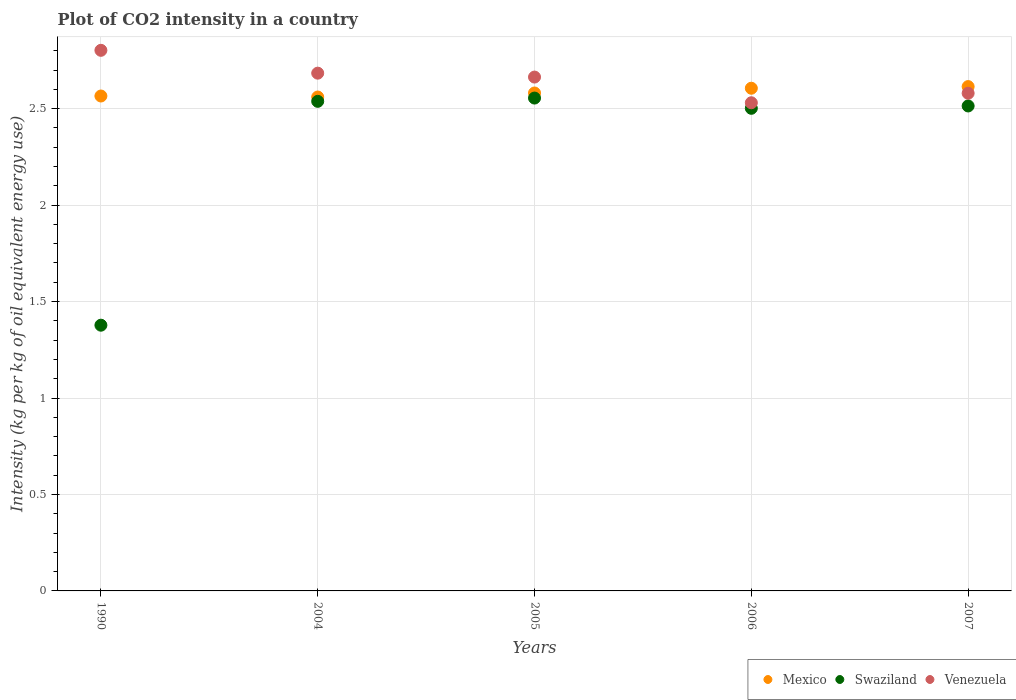What is the CO2 intensity in in Venezuela in 2005?
Your answer should be compact. 2.66. Across all years, what is the maximum CO2 intensity in in Swaziland?
Provide a short and direct response. 2.55. Across all years, what is the minimum CO2 intensity in in Mexico?
Your response must be concise. 2.56. In which year was the CO2 intensity in in Venezuela maximum?
Ensure brevity in your answer.  1990. What is the total CO2 intensity in in Venezuela in the graph?
Your answer should be compact. 13.26. What is the difference between the CO2 intensity in in Mexico in 1990 and that in 2007?
Make the answer very short. -0.05. What is the difference between the CO2 intensity in in Swaziland in 1990 and the CO2 intensity in in Mexico in 2007?
Make the answer very short. -1.24. What is the average CO2 intensity in in Mexico per year?
Offer a terse response. 2.59. In the year 2007, what is the difference between the CO2 intensity in in Venezuela and CO2 intensity in in Mexico?
Your response must be concise. -0.03. What is the ratio of the CO2 intensity in in Swaziland in 1990 to that in 2004?
Offer a very short reply. 0.54. Is the CO2 intensity in in Swaziland in 1990 less than that in 2005?
Give a very brief answer. Yes. Is the difference between the CO2 intensity in in Venezuela in 2004 and 2007 greater than the difference between the CO2 intensity in in Mexico in 2004 and 2007?
Keep it short and to the point. Yes. What is the difference between the highest and the second highest CO2 intensity in in Mexico?
Make the answer very short. 0.01. What is the difference between the highest and the lowest CO2 intensity in in Swaziland?
Make the answer very short. 1.18. In how many years, is the CO2 intensity in in Venezuela greater than the average CO2 intensity in in Venezuela taken over all years?
Keep it short and to the point. 3. Is the CO2 intensity in in Venezuela strictly greater than the CO2 intensity in in Swaziland over the years?
Provide a succinct answer. Yes. Is the CO2 intensity in in Venezuela strictly less than the CO2 intensity in in Mexico over the years?
Provide a succinct answer. No. What is the difference between two consecutive major ticks on the Y-axis?
Keep it short and to the point. 0.5. Does the graph contain any zero values?
Provide a short and direct response. No. Does the graph contain grids?
Ensure brevity in your answer.  Yes. Where does the legend appear in the graph?
Keep it short and to the point. Bottom right. What is the title of the graph?
Give a very brief answer. Plot of CO2 intensity in a country. What is the label or title of the Y-axis?
Your response must be concise. Intensity (kg per kg of oil equivalent energy use). What is the Intensity (kg per kg of oil equivalent energy use) in Mexico in 1990?
Make the answer very short. 2.57. What is the Intensity (kg per kg of oil equivalent energy use) of Swaziland in 1990?
Offer a very short reply. 1.38. What is the Intensity (kg per kg of oil equivalent energy use) of Venezuela in 1990?
Offer a terse response. 2.8. What is the Intensity (kg per kg of oil equivalent energy use) in Mexico in 2004?
Provide a succinct answer. 2.56. What is the Intensity (kg per kg of oil equivalent energy use) in Swaziland in 2004?
Your response must be concise. 2.54. What is the Intensity (kg per kg of oil equivalent energy use) in Venezuela in 2004?
Provide a succinct answer. 2.68. What is the Intensity (kg per kg of oil equivalent energy use) in Mexico in 2005?
Ensure brevity in your answer.  2.58. What is the Intensity (kg per kg of oil equivalent energy use) in Swaziland in 2005?
Keep it short and to the point. 2.55. What is the Intensity (kg per kg of oil equivalent energy use) in Venezuela in 2005?
Give a very brief answer. 2.66. What is the Intensity (kg per kg of oil equivalent energy use) in Mexico in 2006?
Your answer should be compact. 2.61. What is the Intensity (kg per kg of oil equivalent energy use) of Swaziland in 2006?
Provide a succinct answer. 2.5. What is the Intensity (kg per kg of oil equivalent energy use) in Venezuela in 2006?
Keep it short and to the point. 2.53. What is the Intensity (kg per kg of oil equivalent energy use) in Mexico in 2007?
Offer a terse response. 2.61. What is the Intensity (kg per kg of oil equivalent energy use) in Swaziland in 2007?
Provide a succinct answer. 2.51. What is the Intensity (kg per kg of oil equivalent energy use) of Venezuela in 2007?
Provide a short and direct response. 2.58. Across all years, what is the maximum Intensity (kg per kg of oil equivalent energy use) in Mexico?
Your response must be concise. 2.61. Across all years, what is the maximum Intensity (kg per kg of oil equivalent energy use) in Swaziland?
Keep it short and to the point. 2.55. Across all years, what is the maximum Intensity (kg per kg of oil equivalent energy use) in Venezuela?
Provide a succinct answer. 2.8. Across all years, what is the minimum Intensity (kg per kg of oil equivalent energy use) in Mexico?
Offer a terse response. 2.56. Across all years, what is the minimum Intensity (kg per kg of oil equivalent energy use) of Swaziland?
Make the answer very short. 1.38. Across all years, what is the minimum Intensity (kg per kg of oil equivalent energy use) in Venezuela?
Offer a terse response. 2.53. What is the total Intensity (kg per kg of oil equivalent energy use) of Mexico in the graph?
Give a very brief answer. 12.93. What is the total Intensity (kg per kg of oil equivalent energy use) of Swaziland in the graph?
Keep it short and to the point. 11.49. What is the total Intensity (kg per kg of oil equivalent energy use) of Venezuela in the graph?
Keep it short and to the point. 13.26. What is the difference between the Intensity (kg per kg of oil equivalent energy use) in Mexico in 1990 and that in 2004?
Provide a short and direct response. 0.01. What is the difference between the Intensity (kg per kg of oil equivalent energy use) in Swaziland in 1990 and that in 2004?
Ensure brevity in your answer.  -1.16. What is the difference between the Intensity (kg per kg of oil equivalent energy use) in Venezuela in 1990 and that in 2004?
Offer a very short reply. 0.12. What is the difference between the Intensity (kg per kg of oil equivalent energy use) of Mexico in 1990 and that in 2005?
Your answer should be very brief. -0.02. What is the difference between the Intensity (kg per kg of oil equivalent energy use) of Swaziland in 1990 and that in 2005?
Ensure brevity in your answer.  -1.18. What is the difference between the Intensity (kg per kg of oil equivalent energy use) of Venezuela in 1990 and that in 2005?
Make the answer very short. 0.14. What is the difference between the Intensity (kg per kg of oil equivalent energy use) of Mexico in 1990 and that in 2006?
Keep it short and to the point. -0.04. What is the difference between the Intensity (kg per kg of oil equivalent energy use) in Swaziland in 1990 and that in 2006?
Make the answer very short. -1.12. What is the difference between the Intensity (kg per kg of oil equivalent energy use) of Venezuela in 1990 and that in 2006?
Your answer should be compact. 0.27. What is the difference between the Intensity (kg per kg of oil equivalent energy use) of Mexico in 1990 and that in 2007?
Provide a succinct answer. -0.05. What is the difference between the Intensity (kg per kg of oil equivalent energy use) in Swaziland in 1990 and that in 2007?
Provide a succinct answer. -1.14. What is the difference between the Intensity (kg per kg of oil equivalent energy use) of Venezuela in 1990 and that in 2007?
Keep it short and to the point. 0.22. What is the difference between the Intensity (kg per kg of oil equivalent energy use) in Mexico in 2004 and that in 2005?
Offer a terse response. -0.02. What is the difference between the Intensity (kg per kg of oil equivalent energy use) of Swaziland in 2004 and that in 2005?
Offer a terse response. -0.02. What is the difference between the Intensity (kg per kg of oil equivalent energy use) in Venezuela in 2004 and that in 2005?
Your answer should be compact. 0.02. What is the difference between the Intensity (kg per kg of oil equivalent energy use) in Mexico in 2004 and that in 2006?
Offer a terse response. -0.05. What is the difference between the Intensity (kg per kg of oil equivalent energy use) in Swaziland in 2004 and that in 2006?
Your response must be concise. 0.04. What is the difference between the Intensity (kg per kg of oil equivalent energy use) in Venezuela in 2004 and that in 2006?
Your response must be concise. 0.15. What is the difference between the Intensity (kg per kg of oil equivalent energy use) in Mexico in 2004 and that in 2007?
Make the answer very short. -0.05. What is the difference between the Intensity (kg per kg of oil equivalent energy use) of Swaziland in 2004 and that in 2007?
Give a very brief answer. 0.02. What is the difference between the Intensity (kg per kg of oil equivalent energy use) of Venezuela in 2004 and that in 2007?
Provide a succinct answer. 0.1. What is the difference between the Intensity (kg per kg of oil equivalent energy use) of Mexico in 2005 and that in 2006?
Offer a terse response. -0.02. What is the difference between the Intensity (kg per kg of oil equivalent energy use) in Swaziland in 2005 and that in 2006?
Your answer should be compact. 0.05. What is the difference between the Intensity (kg per kg of oil equivalent energy use) of Venezuela in 2005 and that in 2006?
Provide a succinct answer. 0.13. What is the difference between the Intensity (kg per kg of oil equivalent energy use) in Mexico in 2005 and that in 2007?
Provide a short and direct response. -0.03. What is the difference between the Intensity (kg per kg of oil equivalent energy use) of Swaziland in 2005 and that in 2007?
Keep it short and to the point. 0.04. What is the difference between the Intensity (kg per kg of oil equivalent energy use) of Venezuela in 2005 and that in 2007?
Your answer should be very brief. 0.08. What is the difference between the Intensity (kg per kg of oil equivalent energy use) in Mexico in 2006 and that in 2007?
Keep it short and to the point. -0.01. What is the difference between the Intensity (kg per kg of oil equivalent energy use) in Swaziland in 2006 and that in 2007?
Keep it short and to the point. -0.01. What is the difference between the Intensity (kg per kg of oil equivalent energy use) of Venezuela in 2006 and that in 2007?
Offer a terse response. -0.05. What is the difference between the Intensity (kg per kg of oil equivalent energy use) in Mexico in 1990 and the Intensity (kg per kg of oil equivalent energy use) in Swaziland in 2004?
Provide a short and direct response. 0.03. What is the difference between the Intensity (kg per kg of oil equivalent energy use) in Mexico in 1990 and the Intensity (kg per kg of oil equivalent energy use) in Venezuela in 2004?
Make the answer very short. -0.12. What is the difference between the Intensity (kg per kg of oil equivalent energy use) in Swaziland in 1990 and the Intensity (kg per kg of oil equivalent energy use) in Venezuela in 2004?
Provide a short and direct response. -1.31. What is the difference between the Intensity (kg per kg of oil equivalent energy use) in Mexico in 1990 and the Intensity (kg per kg of oil equivalent energy use) in Swaziland in 2005?
Ensure brevity in your answer.  0.01. What is the difference between the Intensity (kg per kg of oil equivalent energy use) of Mexico in 1990 and the Intensity (kg per kg of oil equivalent energy use) of Venezuela in 2005?
Make the answer very short. -0.1. What is the difference between the Intensity (kg per kg of oil equivalent energy use) of Swaziland in 1990 and the Intensity (kg per kg of oil equivalent energy use) of Venezuela in 2005?
Make the answer very short. -1.29. What is the difference between the Intensity (kg per kg of oil equivalent energy use) in Mexico in 1990 and the Intensity (kg per kg of oil equivalent energy use) in Swaziland in 2006?
Your answer should be compact. 0.06. What is the difference between the Intensity (kg per kg of oil equivalent energy use) of Mexico in 1990 and the Intensity (kg per kg of oil equivalent energy use) of Venezuela in 2006?
Ensure brevity in your answer.  0.04. What is the difference between the Intensity (kg per kg of oil equivalent energy use) in Swaziland in 1990 and the Intensity (kg per kg of oil equivalent energy use) in Venezuela in 2006?
Your response must be concise. -1.15. What is the difference between the Intensity (kg per kg of oil equivalent energy use) in Mexico in 1990 and the Intensity (kg per kg of oil equivalent energy use) in Swaziland in 2007?
Your answer should be compact. 0.05. What is the difference between the Intensity (kg per kg of oil equivalent energy use) of Mexico in 1990 and the Intensity (kg per kg of oil equivalent energy use) of Venezuela in 2007?
Offer a terse response. -0.01. What is the difference between the Intensity (kg per kg of oil equivalent energy use) in Swaziland in 1990 and the Intensity (kg per kg of oil equivalent energy use) in Venezuela in 2007?
Ensure brevity in your answer.  -1.2. What is the difference between the Intensity (kg per kg of oil equivalent energy use) of Mexico in 2004 and the Intensity (kg per kg of oil equivalent energy use) of Swaziland in 2005?
Ensure brevity in your answer.  0.01. What is the difference between the Intensity (kg per kg of oil equivalent energy use) in Mexico in 2004 and the Intensity (kg per kg of oil equivalent energy use) in Venezuela in 2005?
Your response must be concise. -0.1. What is the difference between the Intensity (kg per kg of oil equivalent energy use) of Swaziland in 2004 and the Intensity (kg per kg of oil equivalent energy use) of Venezuela in 2005?
Keep it short and to the point. -0.13. What is the difference between the Intensity (kg per kg of oil equivalent energy use) of Mexico in 2004 and the Intensity (kg per kg of oil equivalent energy use) of Swaziland in 2006?
Your response must be concise. 0.06. What is the difference between the Intensity (kg per kg of oil equivalent energy use) of Mexico in 2004 and the Intensity (kg per kg of oil equivalent energy use) of Venezuela in 2006?
Provide a short and direct response. 0.03. What is the difference between the Intensity (kg per kg of oil equivalent energy use) of Swaziland in 2004 and the Intensity (kg per kg of oil equivalent energy use) of Venezuela in 2006?
Your answer should be compact. 0.01. What is the difference between the Intensity (kg per kg of oil equivalent energy use) of Mexico in 2004 and the Intensity (kg per kg of oil equivalent energy use) of Swaziland in 2007?
Provide a short and direct response. 0.05. What is the difference between the Intensity (kg per kg of oil equivalent energy use) of Mexico in 2004 and the Intensity (kg per kg of oil equivalent energy use) of Venezuela in 2007?
Keep it short and to the point. -0.02. What is the difference between the Intensity (kg per kg of oil equivalent energy use) in Swaziland in 2004 and the Intensity (kg per kg of oil equivalent energy use) in Venezuela in 2007?
Provide a short and direct response. -0.04. What is the difference between the Intensity (kg per kg of oil equivalent energy use) of Mexico in 2005 and the Intensity (kg per kg of oil equivalent energy use) of Swaziland in 2006?
Make the answer very short. 0.08. What is the difference between the Intensity (kg per kg of oil equivalent energy use) in Mexico in 2005 and the Intensity (kg per kg of oil equivalent energy use) in Venezuela in 2006?
Your answer should be very brief. 0.05. What is the difference between the Intensity (kg per kg of oil equivalent energy use) of Swaziland in 2005 and the Intensity (kg per kg of oil equivalent energy use) of Venezuela in 2006?
Make the answer very short. 0.02. What is the difference between the Intensity (kg per kg of oil equivalent energy use) in Mexico in 2005 and the Intensity (kg per kg of oil equivalent energy use) in Swaziland in 2007?
Make the answer very short. 0.07. What is the difference between the Intensity (kg per kg of oil equivalent energy use) in Mexico in 2005 and the Intensity (kg per kg of oil equivalent energy use) in Venezuela in 2007?
Offer a very short reply. 0. What is the difference between the Intensity (kg per kg of oil equivalent energy use) in Swaziland in 2005 and the Intensity (kg per kg of oil equivalent energy use) in Venezuela in 2007?
Provide a succinct answer. -0.03. What is the difference between the Intensity (kg per kg of oil equivalent energy use) in Mexico in 2006 and the Intensity (kg per kg of oil equivalent energy use) in Swaziland in 2007?
Offer a very short reply. 0.09. What is the difference between the Intensity (kg per kg of oil equivalent energy use) in Mexico in 2006 and the Intensity (kg per kg of oil equivalent energy use) in Venezuela in 2007?
Offer a very short reply. 0.03. What is the difference between the Intensity (kg per kg of oil equivalent energy use) of Swaziland in 2006 and the Intensity (kg per kg of oil equivalent energy use) of Venezuela in 2007?
Offer a very short reply. -0.08. What is the average Intensity (kg per kg of oil equivalent energy use) in Mexico per year?
Your answer should be compact. 2.59. What is the average Intensity (kg per kg of oil equivalent energy use) of Swaziland per year?
Ensure brevity in your answer.  2.3. What is the average Intensity (kg per kg of oil equivalent energy use) of Venezuela per year?
Provide a short and direct response. 2.65. In the year 1990, what is the difference between the Intensity (kg per kg of oil equivalent energy use) of Mexico and Intensity (kg per kg of oil equivalent energy use) of Swaziland?
Provide a succinct answer. 1.19. In the year 1990, what is the difference between the Intensity (kg per kg of oil equivalent energy use) of Mexico and Intensity (kg per kg of oil equivalent energy use) of Venezuela?
Keep it short and to the point. -0.24. In the year 1990, what is the difference between the Intensity (kg per kg of oil equivalent energy use) of Swaziland and Intensity (kg per kg of oil equivalent energy use) of Venezuela?
Provide a short and direct response. -1.43. In the year 2004, what is the difference between the Intensity (kg per kg of oil equivalent energy use) of Mexico and Intensity (kg per kg of oil equivalent energy use) of Swaziland?
Offer a very short reply. 0.02. In the year 2004, what is the difference between the Intensity (kg per kg of oil equivalent energy use) in Mexico and Intensity (kg per kg of oil equivalent energy use) in Venezuela?
Offer a very short reply. -0.12. In the year 2004, what is the difference between the Intensity (kg per kg of oil equivalent energy use) in Swaziland and Intensity (kg per kg of oil equivalent energy use) in Venezuela?
Your response must be concise. -0.15. In the year 2005, what is the difference between the Intensity (kg per kg of oil equivalent energy use) in Mexico and Intensity (kg per kg of oil equivalent energy use) in Swaziland?
Provide a short and direct response. 0.03. In the year 2005, what is the difference between the Intensity (kg per kg of oil equivalent energy use) of Mexico and Intensity (kg per kg of oil equivalent energy use) of Venezuela?
Ensure brevity in your answer.  -0.08. In the year 2005, what is the difference between the Intensity (kg per kg of oil equivalent energy use) of Swaziland and Intensity (kg per kg of oil equivalent energy use) of Venezuela?
Your answer should be very brief. -0.11. In the year 2006, what is the difference between the Intensity (kg per kg of oil equivalent energy use) of Mexico and Intensity (kg per kg of oil equivalent energy use) of Swaziland?
Your answer should be very brief. 0.1. In the year 2006, what is the difference between the Intensity (kg per kg of oil equivalent energy use) in Mexico and Intensity (kg per kg of oil equivalent energy use) in Venezuela?
Your response must be concise. 0.08. In the year 2006, what is the difference between the Intensity (kg per kg of oil equivalent energy use) of Swaziland and Intensity (kg per kg of oil equivalent energy use) of Venezuela?
Provide a succinct answer. -0.03. In the year 2007, what is the difference between the Intensity (kg per kg of oil equivalent energy use) of Mexico and Intensity (kg per kg of oil equivalent energy use) of Swaziland?
Ensure brevity in your answer.  0.1. In the year 2007, what is the difference between the Intensity (kg per kg of oil equivalent energy use) of Mexico and Intensity (kg per kg of oil equivalent energy use) of Venezuela?
Ensure brevity in your answer.  0.03. In the year 2007, what is the difference between the Intensity (kg per kg of oil equivalent energy use) of Swaziland and Intensity (kg per kg of oil equivalent energy use) of Venezuela?
Keep it short and to the point. -0.07. What is the ratio of the Intensity (kg per kg of oil equivalent energy use) in Swaziland in 1990 to that in 2004?
Keep it short and to the point. 0.54. What is the ratio of the Intensity (kg per kg of oil equivalent energy use) in Venezuela in 1990 to that in 2004?
Your answer should be very brief. 1.04. What is the ratio of the Intensity (kg per kg of oil equivalent energy use) of Mexico in 1990 to that in 2005?
Ensure brevity in your answer.  0.99. What is the ratio of the Intensity (kg per kg of oil equivalent energy use) of Swaziland in 1990 to that in 2005?
Your answer should be compact. 0.54. What is the ratio of the Intensity (kg per kg of oil equivalent energy use) in Venezuela in 1990 to that in 2005?
Give a very brief answer. 1.05. What is the ratio of the Intensity (kg per kg of oil equivalent energy use) in Mexico in 1990 to that in 2006?
Ensure brevity in your answer.  0.98. What is the ratio of the Intensity (kg per kg of oil equivalent energy use) of Swaziland in 1990 to that in 2006?
Keep it short and to the point. 0.55. What is the ratio of the Intensity (kg per kg of oil equivalent energy use) in Venezuela in 1990 to that in 2006?
Your response must be concise. 1.11. What is the ratio of the Intensity (kg per kg of oil equivalent energy use) in Mexico in 1990 to that in 2007?
Offer a terse response. 0.98. What is the ratio of the Intensity (kg per kg of oil equivalent energy use) in Swaziland in 1990 to that in 2007?
Keep it short and to the point. 0.55. What is the ratio of the Intensity (kg per kg of oil equivalent energy use) of Venezuela in 1990 to that in 2007?
Make the answer very short. 1.09. What is the ratio of the Intensity (kg per kg of oil equivalent energy use) of Mexico in 2004 to that in 2005?
Ensure brevity in your answer.  0.99. What is the ratio of the Intensity (kg per kg of oil equivalent energy use) in Venezuela in 2004 to that in 2005?
Make the answer very short. 1.01. What is the ratio of the Intensity (kg per kg of oil equivalent energy use) in Mexico in 2004 to that in 2006?
Provide a succinct answer. 0.98. What is the ratio of the Intensity (kg per kg of oil equivalent energy use) of Swaziland in 2004 to that in 2006?
Your answer should be very brief. 1.01. What is the ratio of the Intensity (kg per kg of oil equivalent energy use) in Venezuela in 2004 to that in 2006?
Your response must be concise. 1.06. What is the ratio of the Intensity (kg per kg of oil equivalent energy use) of Mexico in 2004 to that in 2007?
Keep it short and to the point. 0.98. What is the ratio of the Intensity (kg per kg of oil equivalent energy use) in Swaziland in 2004 to that in 2007?
Provide a short and direct response. 1.01. What is the ratio of the Intensity (kg per kg of oil equivalent energy use) in Venezuela in 2004 to that in 2007?
Make the answer very short. 1.04. What is the ratio of the Intensity (kg per kg of oil equivalent energy use) of Swaziland in 2005 to that in 2006?
Provide a short and direct response. 1.02. What is the ratio of the Intensity (kg per kg of oil equivalent energy use) of Venezuela in 2005 to that in 2006?
Give a very brief answer. 1.05. What is the ratio of the Intensity (kg per kg of oil equivalent energy use) of Mexico in 2005 to that in 2007?
Keep it short and to the point. 0.99. What is the ratio of the Intensity (kg per kg of oil equivalent energy use) in Swaziland in 2005 to that in 2007?
Keep it short and to the point. 1.02. What is the ratio of the Intensity (kg per kg of oil equivalent energy use) of Venezuela in 2005 to that in 2007?
Keep it short and to the point. 1.03. What is the ratio of the Intensity (kg per kg of oil equivalent energy use) in Mexico in 2006 to that in 2007?
Keep it short and to the point. 1. What is the ratio of the Intensity (kg per kg of oil equivalent energy use) of Swaziland in 2006 to that in 2007?
Your response must be concise. 1. What is the ratio of the Intensity (kg per kg of oil equivalent energy use) of Venezuela in 2006 to that in 2007?
Keep it short and to the point. 0.98. What is the difference between the highest and the second highest Intensity (kg per kg of oil equivalent energy use) in Mexico?
Provide a short and direct response. 0.01. What is the difference between the highest and the second highest Intensity (kg per kg of oil equivalent energy use) in Swaziland?
Offer a very short reply. 0.02. What is the difference between the highest and the second highest Intensity (kg per kg of oil equivalent energy use) of Venezuela?
Keep it short and to the point. 0.12. What is the difference between the highest and the lowest Intensity (kg per kg of oil equivalent energy use) in Mexico?
Your answer should be compact. 0.05. What is the difference between the highest and the lowest Intensity (kg per kg of oil equivalent energy use) in Swaziland?
Your answer should be compact. 1.18. What is the difference between the highest and the lowest Intensity (kg per kg of oil equivalent energy use) in Venezuela?
Provide a short and direct response. 0.27. 